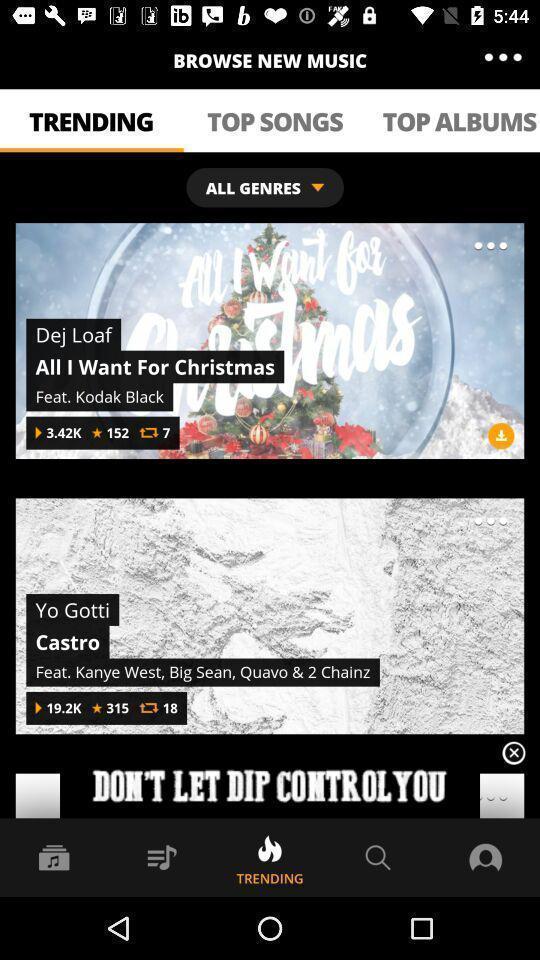What details can you identify in this image? Page displaying trending albums with number of plays. 